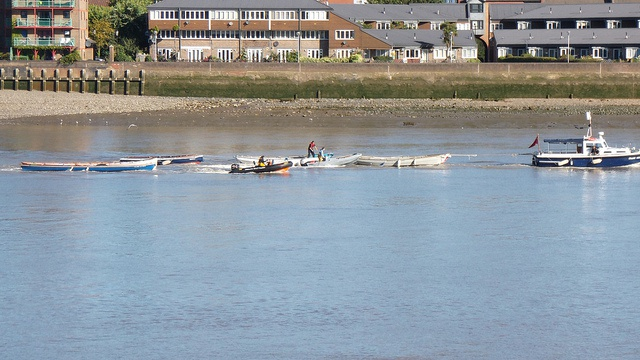Describe the objects in this image and their specific colors. I can see boat in black, white, darkgray, navy, and gray tones, boat in black, lightgray, darkgray, blue, and tan tones, boat in black, lightgray, darkgray, and gray tones, boat in black, ivory, darkgray, lightgray, and tan tones, and boat in black, lightgray, gray, darkgray, and darkblue tones in this image. 